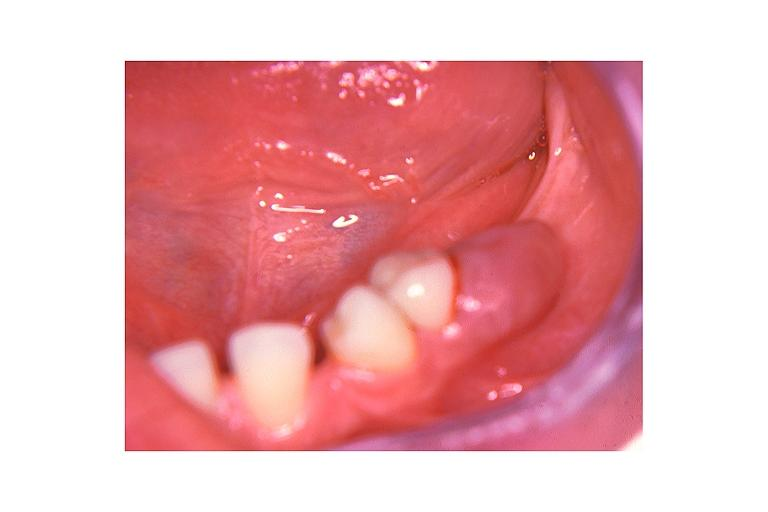where is this?
Answer the question using a single word or phrase. Oral 